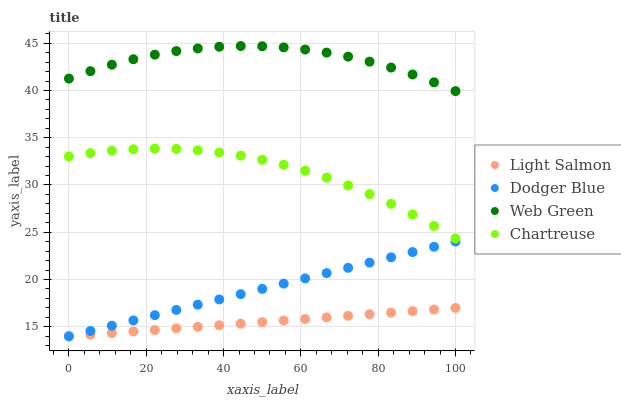Does Light Salmon have the minimum area under the curve?
Answer yes or no. Yes. Does Web Green have the maximum area under the curve?
Answer yes or no. Yes. Does Dodger Blue have the minimum area under the curve?
Answer yes or no. No. Does Dodger Blue have the maximum area under the curve?
Answer yes or no. No. Is Light Salmon the smoothest?
Answer yes or no. Yes. Is Web Green the roughest?
Answer yes or no. Yes. Is Dodger Blue the smoothest?
Answer yes or no. No. Is Dodger Blue the roughest?
Answer yes or no. No. Does Light Salmon have the lowest value?
Answer yes or no. Yes. Does Chartreuse have the lowest value?
Answer yes or no. No. Does Web Green have the highest value?
Answer yes or no. Yes. Does Dodger Blue have the highest value?
Answer yes or no. No. Is Dodger Blue less than Chartreuse?
Answer yes or no. Yes. Is Chartreuse greater than Light Salmon?
Answer yes or no. Yes. Does Dodger Blue intersect Light Salmon?
Answer yes or no. Yes. Is Dodger Blue less than Light Salmon?
Answer yes or no. No. Is Dodger Blue greater than Light Salmon?
Answer yes or no. No. Does Dodger Blue intersect Chartreuse?
Answer yes or no. No. 